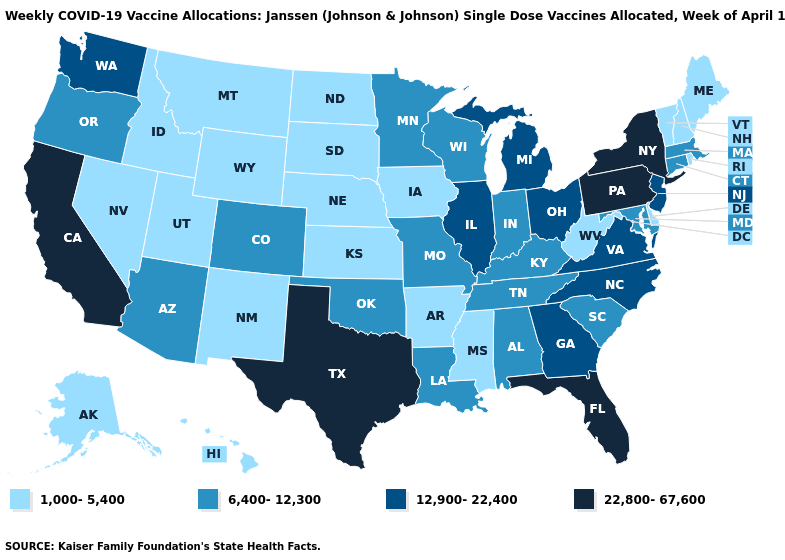Does Georgia have the highest value in the South?
Be succinct. No. What is the highest value in the USA?
Keep it brief. 22,800-67,600. What is the value of New York?
Give a very brief answer. 22,800-67,600. Name the states that have a value in the range 1,000-5,400?
Be succinct. Alaska, Arkansas, Delaware, Hawaii, Idaho, Iowa, Kansas, Maine, Mississippi, Montana, Nebraska, Nevada, New Hampshire, New Mexico, North Dakota, Rhode Island, South Dakota, Utah, Vermont, West Virginia, Wyoming. Name the states that have a value in the range 1,000-5,400?
Quick response, please. Alaska, Arkansas, Delaware, Hawaii, Idaho, Iowa, Kansas, Maine, Mississippi, Montana, Nebraska, Nevada, New Hampshire, New Mexico, North Dakota, Rhode Island, South Dakota, Utah, Vermont, West Virginia, Wyoming. Which states have the lowest value in the MidWest?
Short answer required. Iowa, Kansas, Nebraska, North Dakota, South Dakota. What is the highest value in the South ?
Give a very brief answer. 22,800-67,600. What is the lowest value in the South?
Keep it brief. 1,000-5,400. Among the states that border New Hampshire , which have the lowest value?
Give a very brief answer. Maine, Vermont. What is the value of Indiana?
Give a very brief answer. 6,400-12,300. Which states have the lowest value in the USA?
Short answer required. Alaska, Arkansas, Delaware, Hawaii, Idaho, Iowa, Kansas, Maine, Mississippi, Montana, Nebraska, Nevada, New Hampshire, New Mexico, North Dakota, Rhode Island, South Dakota, Utah, Vermont, West Virginia, Wyoming. Name the states that have a value in the range 6,400-12,300?
Quick response, please. Alabama, Arizona, Colorado, Connecticut, Indiana, Kentucky, Louisiana, Maryland, Massachusetts, Minnesota, Missouri, Oklahoma, Oregon, South Carolina, Tennessee, Wisconsin. How many symbols are there in the legend?
Keep it brief. 4. Does Texas have the highest value in the USA?
Be succinct. Yes. Name the states that have a value in the range 12,900-22,400?
Keep it brief. Georgia, Illinois, Michigan, New Jersey, North Carolina, Ohio, Virginia, Washington. 